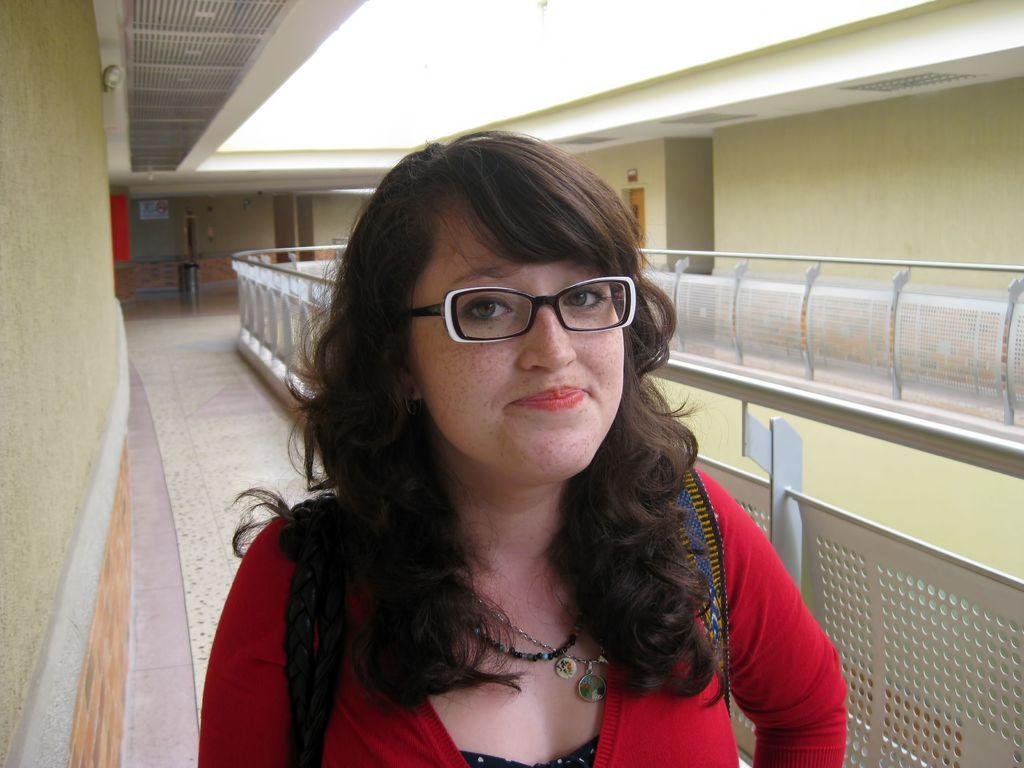What is the primary subject in the image? There is a woman standing in the image. Where is the woman standing? The woman is standing on the floor. What can be seen in the background of the image? There are walls, doors, bins, and railings in the background of the image. What type of chair is the woman sitting on in the image? There is no chair present in the image; the woman is standing. What is the woman's desire in the image? There is no information about the woman's desires in the image. 